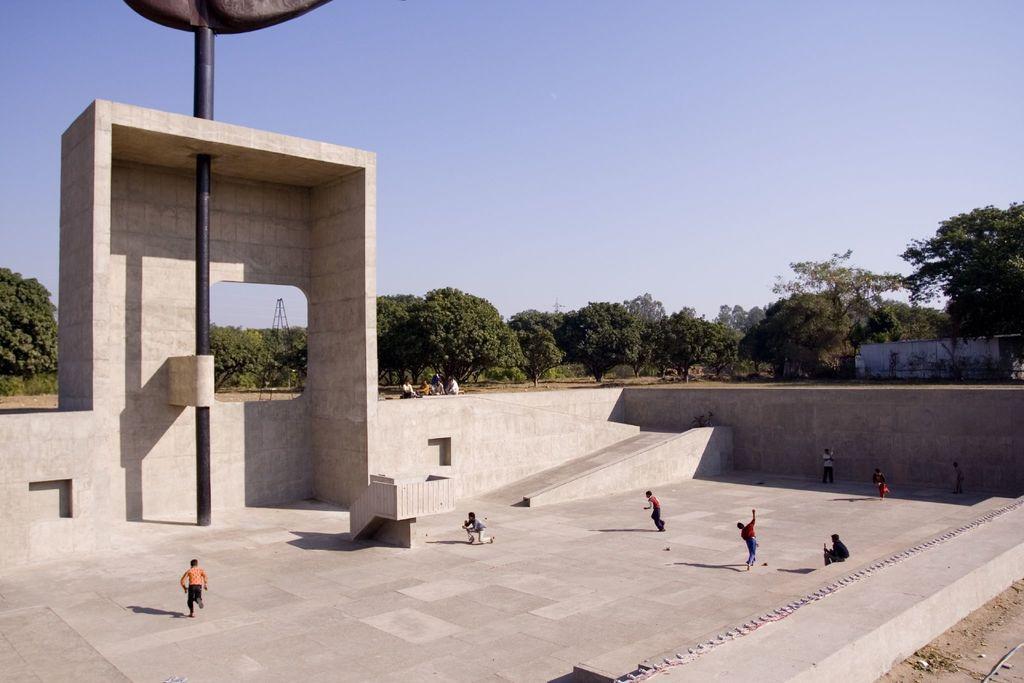Can you describe this image briefly? In this image, there are a few people. We can see the ground and the arch. We can see a pole and a tower. We can see some trees and the wall. We can see the sky. 